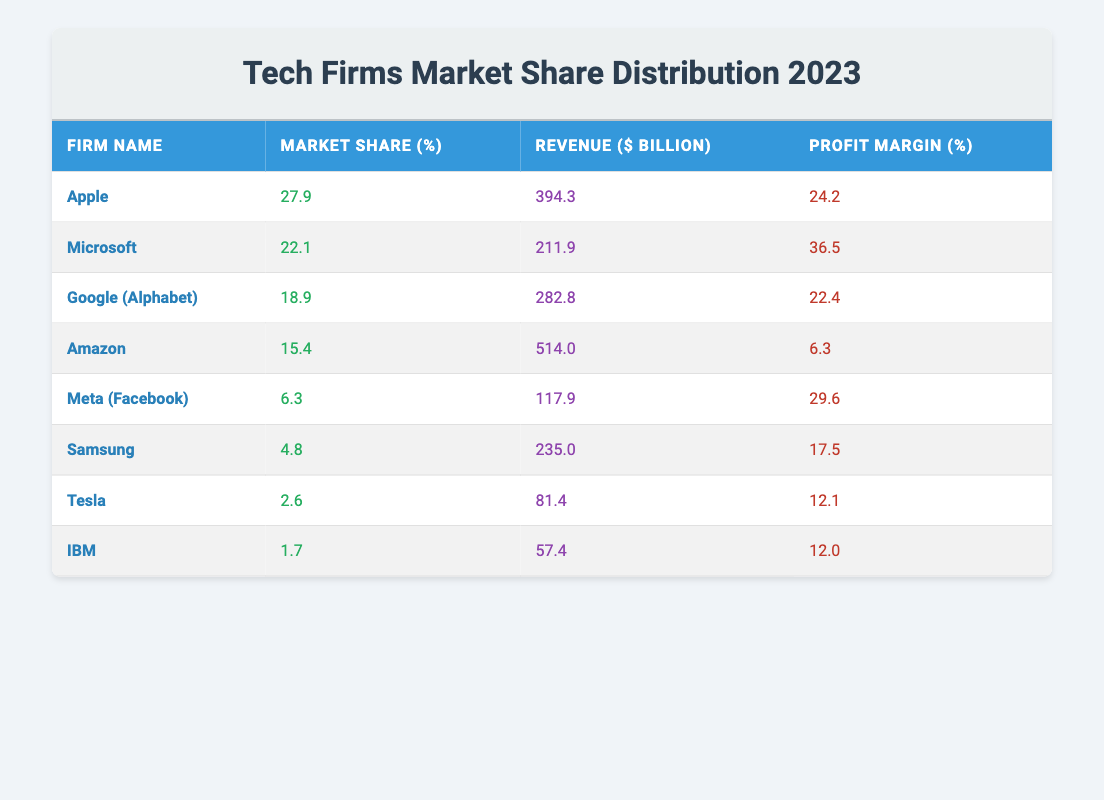What is the market share percentage of Apple in 2023? From the table, I can directly see that Apple's market share percentage is listed as 27.9%.
Answer: 27.9% Which firm has the highest profit margin? By reviewing the profit margin values in the table, I see that Microsoft has a profit margin of 36.5%, which is higher than any other firm's profit margin.
Answer: Microsoft What is the total market share of the top three firms? The top three firms are Apple (27.9%), Microsoft (22.1%), and Google (18.9%). Adding these values gives 27.9 + 22.1 + 18.9 = 68.9%.
Answer: 68.9% Is Amazon's profit margin higher than that of Meta? Amazon has a profit margin of 6.3% while Meta's profit margin is 29.6%. Since 6.3% is less than 29.6%, Amazon's margin is not higher.
Answer: No What is the average revenue of the three firms with the lowest market share? The firms with the lowest market shares are Tesla (81.4 billion), IBM (57.4 billion), and Samsung (235.0 billion). Adding these gives 81.4 + 57.4 + 235.0 = 374.8 billion. Dividing by 3 results in an average revenue of 374.8 / 3 = 124.93 billion.
Answer: 124.93 billion Does Google (Alphabet) have a market share greater than Amazon? Google has a market share of 18.9% and Amazon has 15.4%. Therefore, Google indeed has a greater market share.
Answer: Yes What percentage of the overall market share is held by the firms ranked below Apple? The firms ranked below Apple are Microsoft, Google (Alphabet), Amazon, Meta, Samsung, Tesla, and IBM. Summing their market shares gives 22.1 + 18.9 + 15.4 + 6.3 + 4.8 + 2.6 + 1.7 = 71.8%.
Answer: 71.8% Which firms have a revenue greater than 200 billion? By checking revenues, Apple (394.3 billion), Microsoft (211.9 billion), and Amazon (514.0 billion) have revenues greater than 200 billion.
Answer: Apple, Microsoft, Amazon What is the profit margin difference between Microsoft and Samsung? Microsoft's profit margin is 36.5% and Samsung’s profit margin is 17.5%. The difference is calculated as 36.5 - 17.5 = 19%.
Answer: 19% 